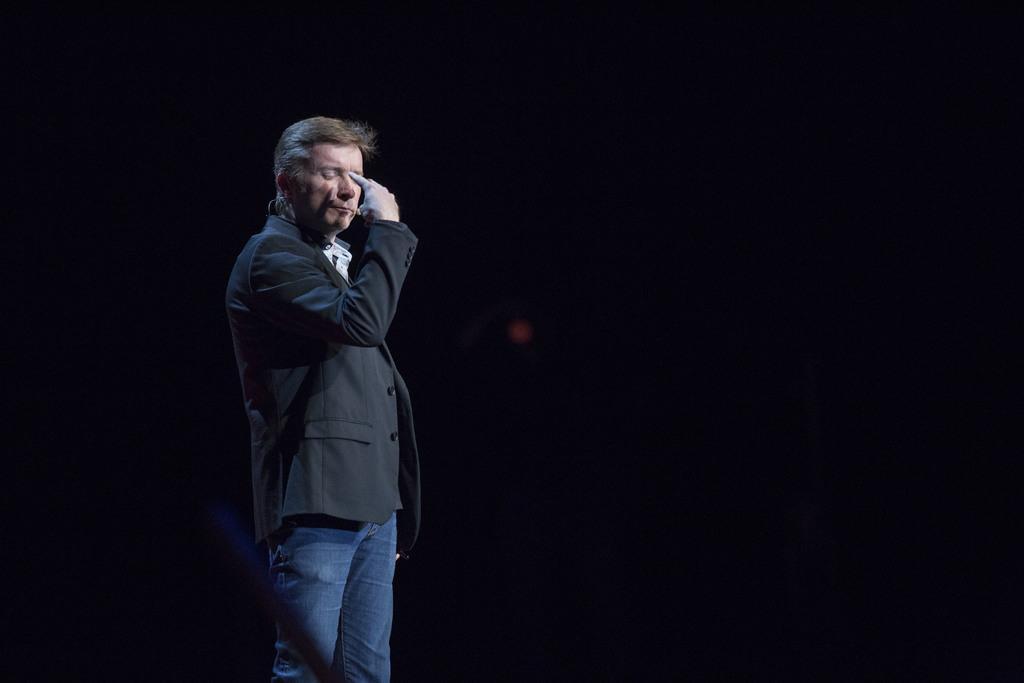Could you give a brief overview of what you see in this image? In this image I can see a person wearing black blazer and blue jeans is standing and I can see the black background. 